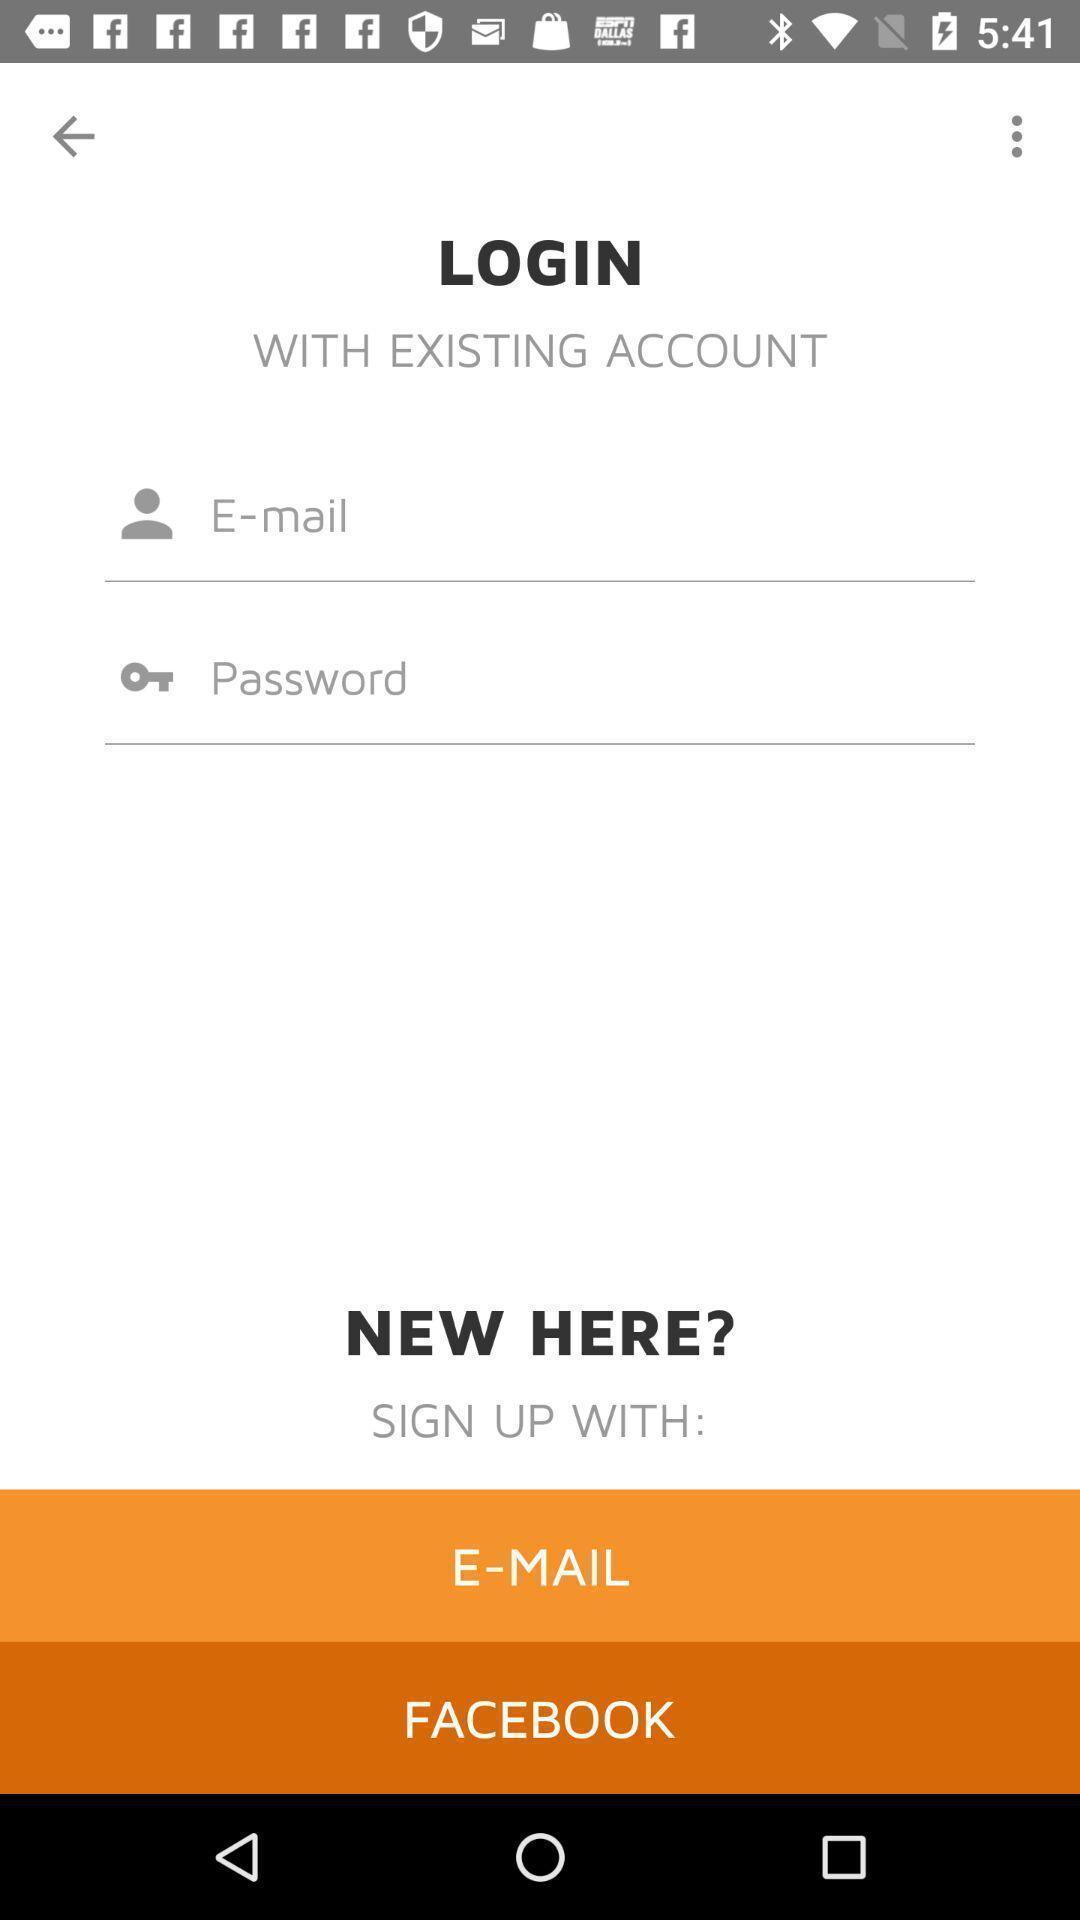Summarize the main components in this picture. Screen displaying the login page. 